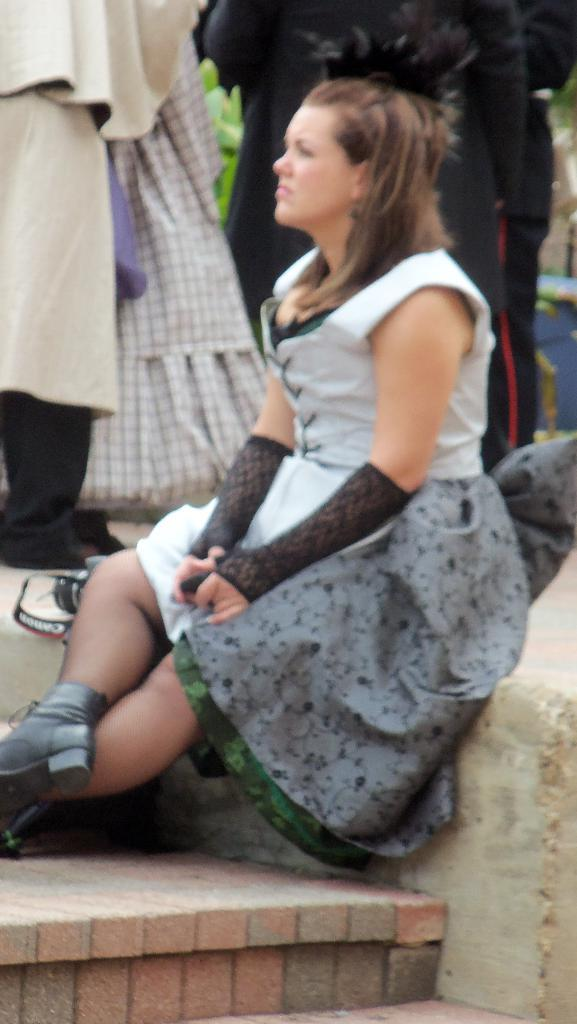What is the lady doing in the image? The lady is sitting on a wall. Are there any other people in the image? Yes, there are persons standing behind the lady. What object is located beside the lady? There is a camera beside the lady. How many women are using the camera in the image? There is no information about women using the camera in the image, as it only mentions the presence of a camera beside the lady. 